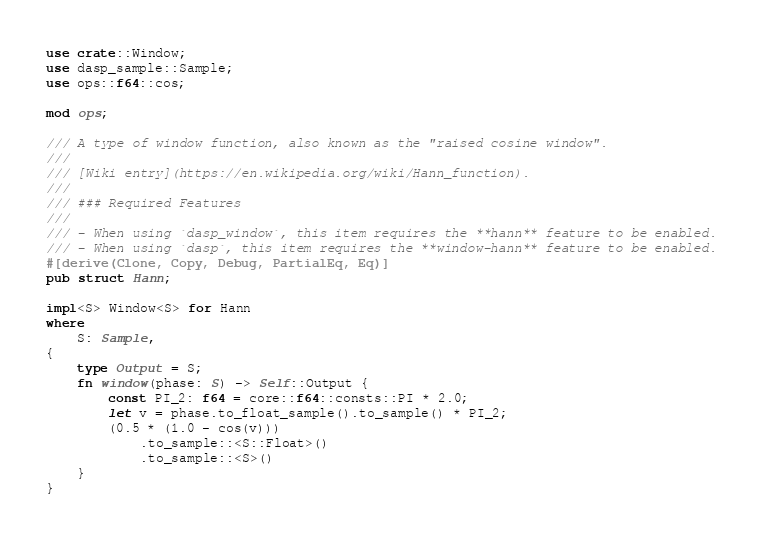Convert code to text. <code><loc_0><loc_0><loc_500><loc_500><_Rust_>use crate::Window;
use dasp_sample::Sample;
use ops::f64::cos;

mod ops;

/// A type of window function, also known as the "raised cosine window".
///
/// [Wiki entry](https://en.wikipedia.org/wiki/Hann_function).
///
/// ### Required Features
///
/// - When using `dasp_window`, this item requires the **hann** feature to be enabled.
/// - When using `dasp`, this item requires the **window-hann** feature to be enabled.
#[derive(Clone, Copy, Debug, PartialEq, Eq)]
pub struct Hann;

impl<S> Window<S> for Hann
where
    S: Sample,
{
    type Output = S;
    fn window(phase: S) -> Self::Output {
        const PI_2: f64 = core::f64::consts::PI * 2.0;
        let v = phase.to_float_sample().to_sample() * PI_2;
        (0.5 * (1.0 - cos(v)))
            .to_sample::<S::Float>()
            .to_sample::<S>()
    }
}
</code> 